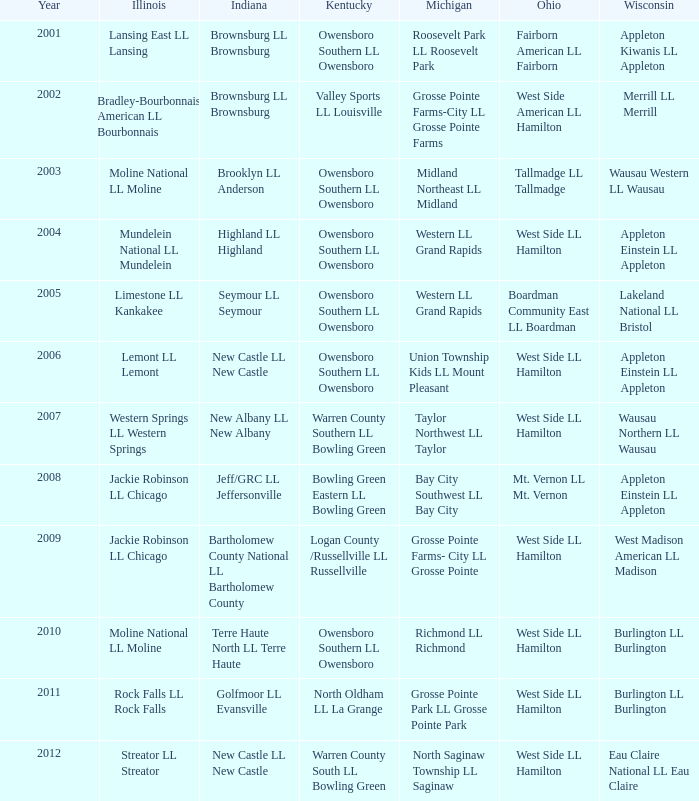Parse the table in full. {'header': ['Year', 'Illinois', 'Indiana', 'Kentucky', 'Michigan', 'Ohio', 'Wisconsin'], 'rows': [['2001', 'Lansing East LL Lansing', 'Brownsburg LL Brownsburg', 'Owensboro Southern LL Owensboro', 'Roosevelt Park LL Roosevelt Park', 'Fairborn American LL Fairborn', 'Appleton Kiwanis LL Appleton'], ['2002', 'Bradley-Bourbonnais American LL Bourbonnais', 'Brownsburg LL Brownsburg', 'Valley Sports LL Louisville', 'Grosse Pointe Farms-City LL Grosse Pointe Farms', 'West Side American LL Hamilton', 'Merrill LL Merrill'], ['2003', 'Moline National LL Moline', 'Brooklyn LL Anderson', 'Owensboro Southern LL Owensboro', 'Midland Northeast LL Midland', 'Tallmadge LL Tallmadge', 'Wausau Western LL Wausau'], ['2004', 'Mundelein National LL Mundelein', 'Highland LL Highland', 'Owensboro Southern LL Owensboro', 'Western LL Grand Rapids', 'West Side LL Hamilton', 'Appleton Einstein LL Appleton'], ['2005', 'Limestone LL Kankakee', 'Seymour LL Seymour', 'Owensboro Southern LL Owensboro', 'Western LL Grand Rapids', 'Boardman Community East LL Boardman', 'Lakeland National LL Bristol'], ['2006', 'Lemont LL Lemont', 'New Castle LL New Castle', 'Owensboro Southern LL Owensboro', 'Union Township Kids LL Mount Pleasant', 'West Side LL Hamilton', 'Appleton Einstein LL Appleton'], ['2007', 'Western Springs LL Western Springs', 'New Albany LL New Albany', 'Warren County Southern LL Bowling Green', 'Taylor Northwest LL Taylor', 'West Side LL Hamilton', 'Wausau Northern LL Wausau'], ['2008', 'Jackie Robinson LL Chicago', 'Jeff/GRC LL Jeffersonville', 'Bowling Green Eastern LL Bowling Green', 'Bay City Southwest LL Bay City', 'Mt. Vernon LL Mt. Vernon', 'Appleton Einstein LL Appleton'], ['2009', 'Jackie Robinson LL Chicago', 'Bartholomew County National LL Bartholomew County', 'Logan County /Russellville LL Russellville', 'Grosse Pointe Farms- City LL Grosse Pointe', 'West Side LL Hamilton', 'West Madison American LL Madison'], ['2010', 'Moline National LL Moline', 'Terre Haute North LL Terre Haute', 'Owensboro Southern LL Owensboro', 'Richmond LL Richmond', 'West Side LL Hamilton', 'Burlington LL Burlington'], ['2011', 'Rock Falls LL Rock Falls', 'Golfmoor LL Evansville', 'North Oldham LL La Grange', 'Grosse Pointe Park LL Grosse Pointe Park', 'West Side LL Hamilton', 'Burlington LL Burlington'], ['2012', 'Streator LL Streator', 'New Castle LL New Castle', 'Warren County South LL Bowling Green', 'North Saginaw Township LL Saginaw', 'West Side LL Hamilton', 'Eau Claire National LL Eau Claire']]} What was the little league team from Ohio when the little league team from Kentucky was Warren County South LL Bowling Green? West Side LL Hamilton. 